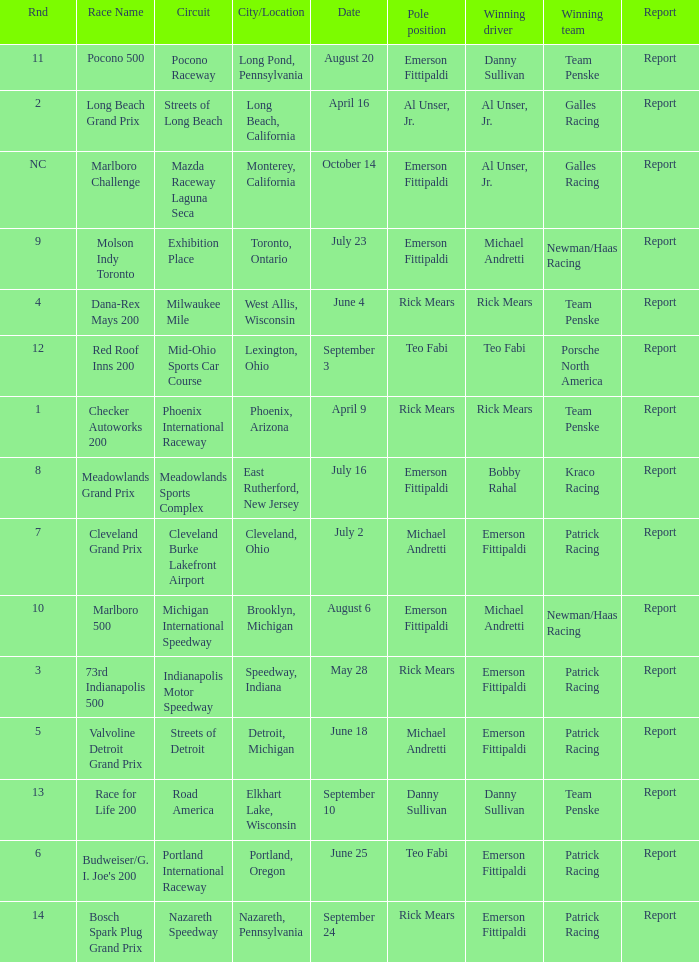What rnds were there for the phoenix international raceway? 1.0. 